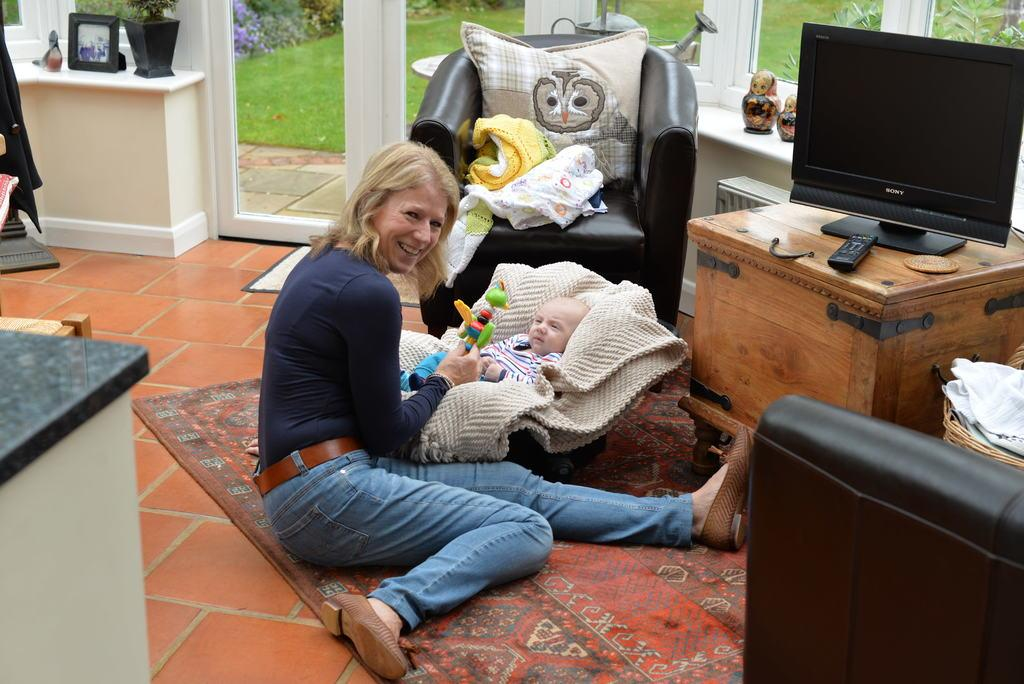Who is present in the image? There is a woman and a baby in the image. What is the woman doing in the image? The woman is sitting in the image. What is the woman holding in the image? The woman is holding a toy in the image. How is the baby positioned in the image? The baby is lying on a cloth in the image. What objects can be seen on the table in the image? There is a TV and a TV remote on the table in the image. What type of vegetable is being used as a pillow for the baby in the image? There is no vegetable present in the image, and the baby is lying on a cloth, not a vegetable. 